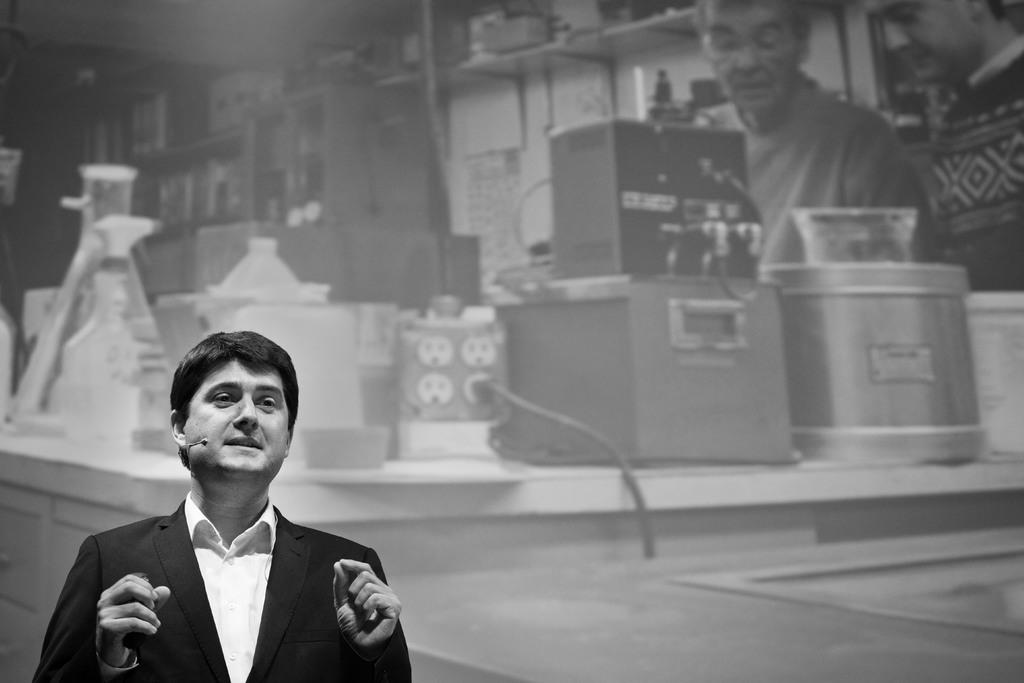Who is the main subject on the left side of the image? There is a man standing at the left side of the image. Can you describe the people in the background of the image? There are two persons standing in the background of the image. What objects can be seen in the image besides the people? There are some boxes visible in the image. How many women are on the roof in the image? There is no roof or women present in the image. 